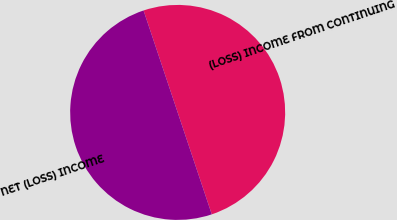Convert chart. <chart><loc_0><loc_0><loc_500><loc_500><pie_chart><fcel>(LOSS) INCOME FROM CONTINUING<fcel>NET (LOSS) INCOME<nl><fcel>50.0%<fcel>50.0%<nl></chart> 